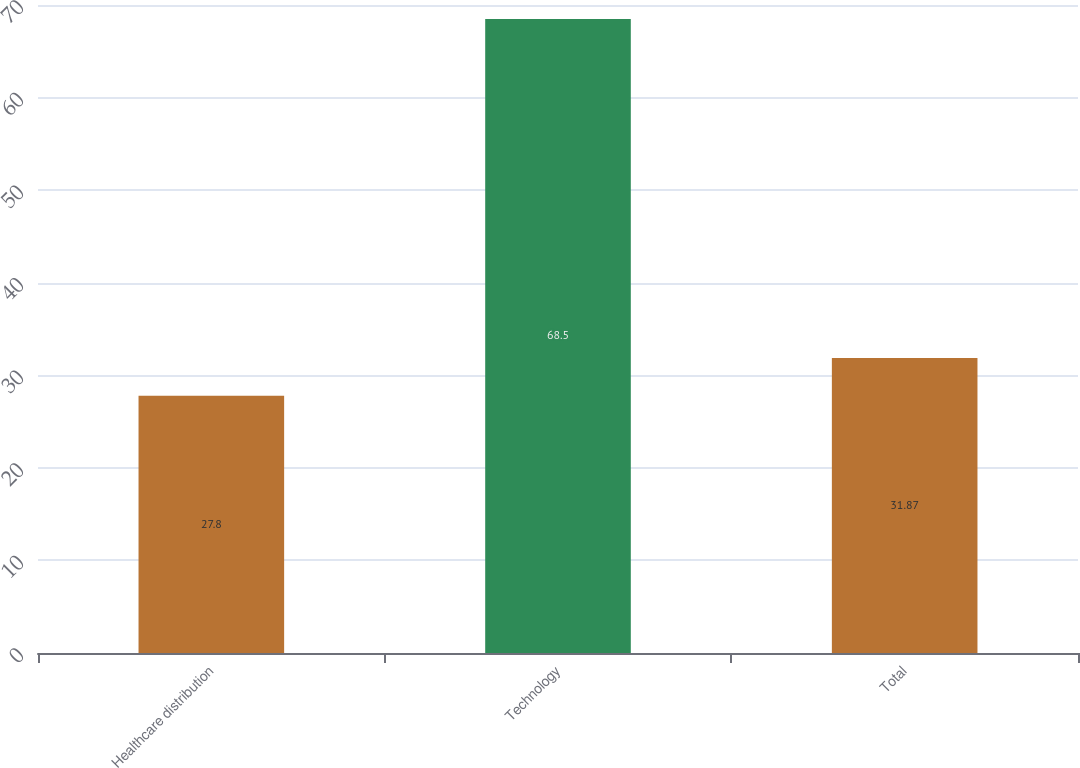<chart> <loc_0><loc_0><loc_500><loc_500><bar_chart><fcel>Healthcare distribution<fcel>Technology<fcel>Total<nl><fcel>27.8<fcel>68.5<fcel>31.87<nl></chart> 